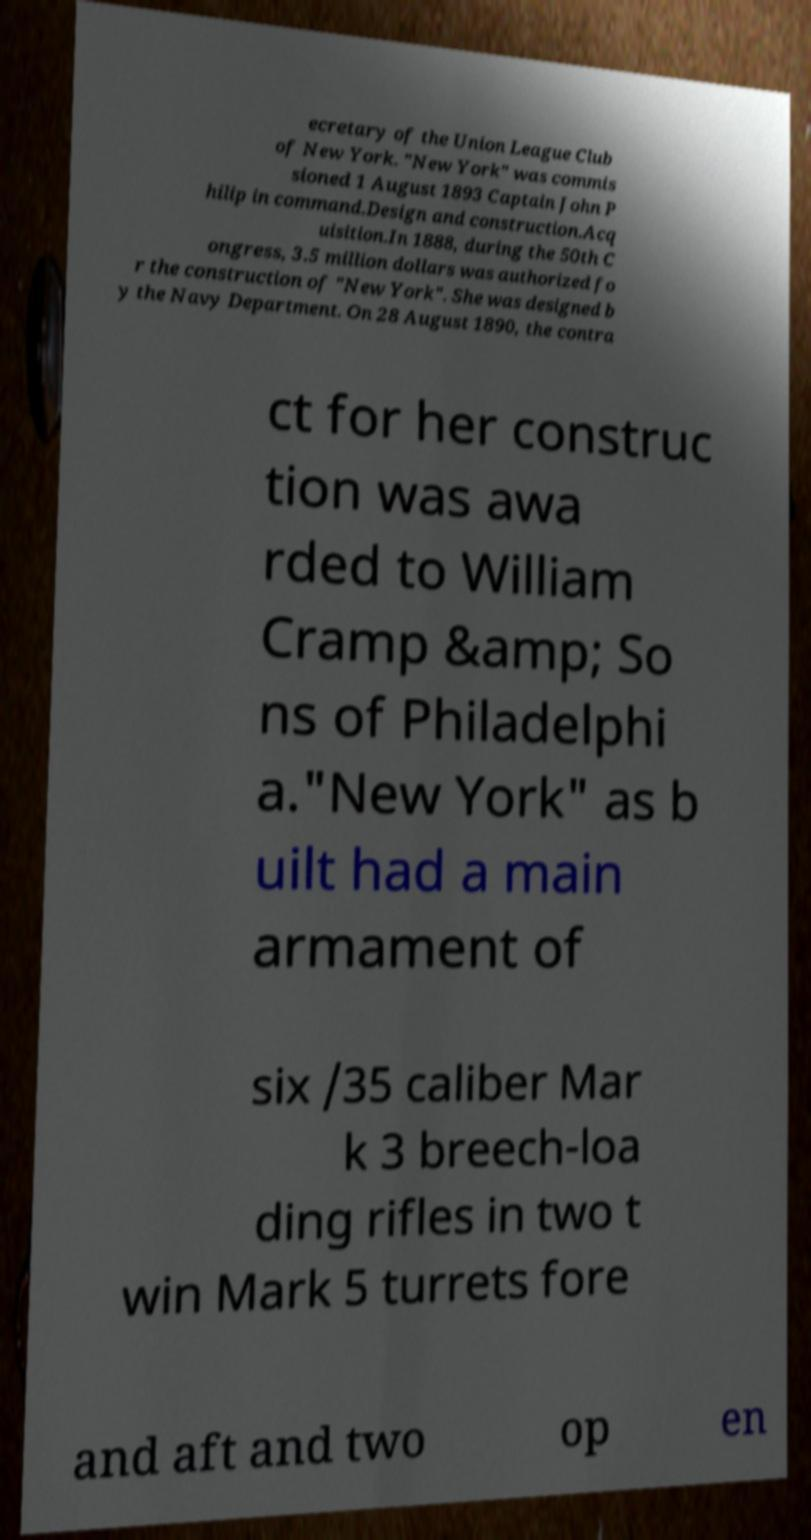For documentation purposes, I need the text within this image transcribed. Could you provide that? ecretary of the Union League Club of New York. "New York" was commis sioned 1 August 1893 Captain John P hilip in command.Design and construction.Acq uisition.In 1888, during the 50th C ongress, 3.5 million dollars was authorized fo r the construction of "New York". She was designed b y the Navy Department. On 28 August 1890, the contra ct for her construc tion was awa rded to William Cramp &amp; So ns of Philadelphi a."New York" as b uilt had a main armament of six /35 caliber Mar k 3 breech-loa ding rifles in two t win Mark 5 turrets fore and aft and two op en 